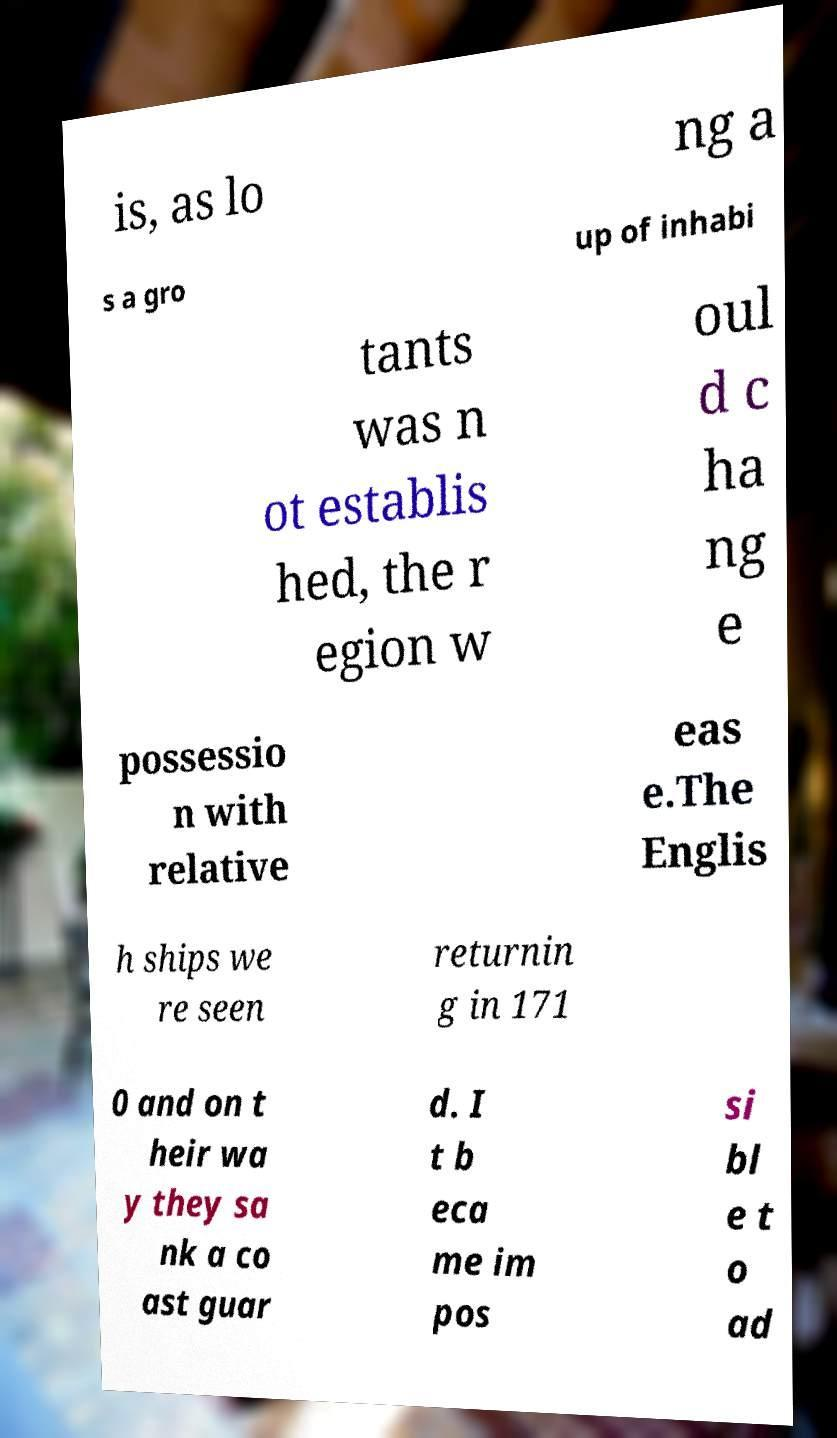Can you accurately transcribe the text from the provided image for me? is, as lo ng a s a gro up of inhabi tants was n ot establis hed, the r egion w oul d c ha ng e possessio n with relative eas e.The Englis h ships we re seen returnin g in 171 0 and on t heir wa y they sa nk a co ast guar d. I t b eca me im pos si bl e t o ad 